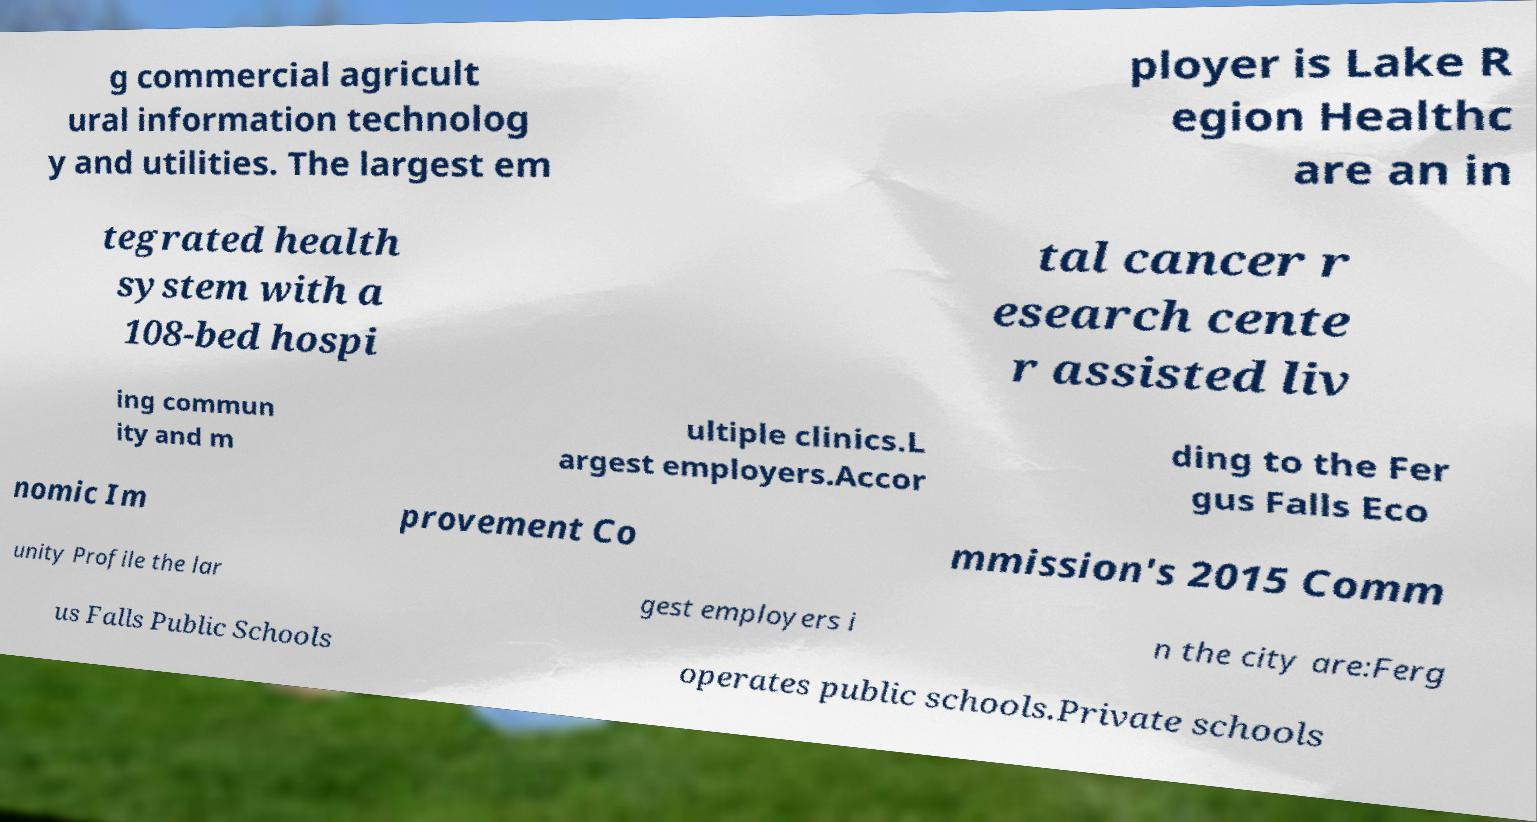Can you read and provide the text displayed in the image?This photo seems to have some interesting text. Can you extract and type it out for me? g commercial agricult ural information technolog y and utilities. The largest em ployer is Lake R egion Healthc are an in tegrated health system with a 108-bed hospi tal cancer r esearch cente r assisted liv ing commun ity and m ultiple clinics.L argest employers.Accor ding to the Fer gus Falls Eco nomic Im provement Co mmission's 2015 Comm unity Profile the lar gest employers i n the city are:Ferg us Falls Public Schools operates public schools.Private schools 